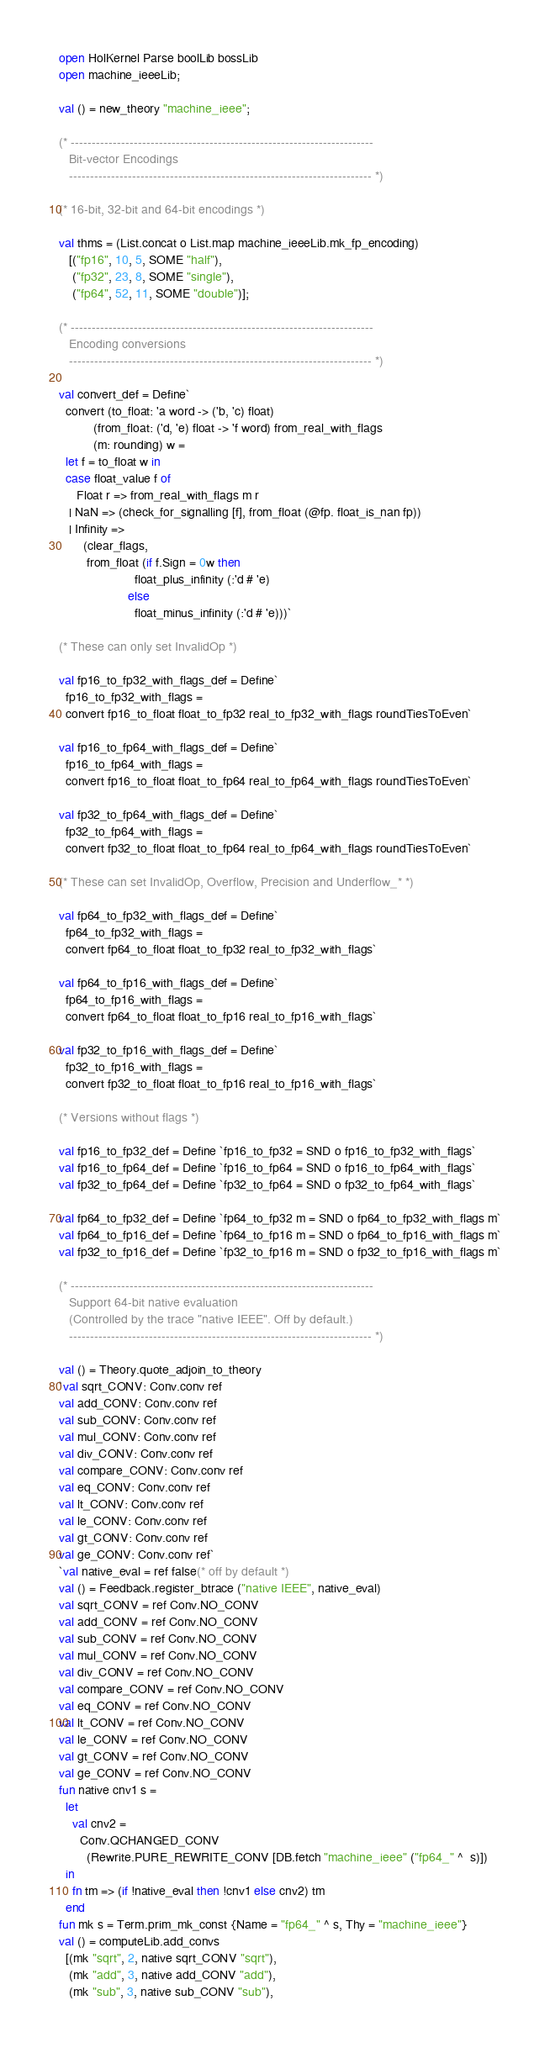<code> <loc_0><loc_0><loc_500><loc_500><_SML_>open HolKernel Parse boolLib bossLib
open machine_ieeeLib;

val () = new_theory "machine_ieee";

(* ------------------------------------------------------------------------
   Bit-vector Encodings
   ------------------------------------------------------------------------ *)

(* 16-bit, 32-bit and 64-bit encodings *)

val thms = (List.concat o List.map machine_ieeeLib.mk_fp_encoding)
   [("fp16", 10, 5, SOME "half"),
    ("fp32", 23, 8, SOME "single"),
    ("fp64", 52, 11, SOME "double")];

(* ------------------------------------------------------------------------
   Encoding conversions
   ------------------------------------------------------------------------ *)

val convert_def = Define`
  convert (to_float: 'a word -> ('b, 'c) float)
          (from_float: ('d, 'e) float -> 'f word) from_real_with_flags
          (m: rounding) w =
  let f = to_float w in
  case float_value f of
     Float r => from_real_with_flags m r
   | NaN => (check_for_signalling [f], from_float (@fp. float_is_nan fp))
   | Infinity =>
       (clear_flags,
        from_float (if f.Sign = 0w then
                      float_plus_infinity (:'d # 'e)
                    else
                      float_minus_infinity (:'d # 'e)))`

(* These can only set InvalidOp *)

val fp16_to_fp32_with_flags_def = Define`
  fp16_to_fp32_with_flags =
  convert fp16_to_float float_to_fp32 real_to_fp32_with_flags roundTiesToEven`

val fp16_to_fp64_with_flags_def = Define`
  fp16_to_fp64_with_flags =
  convert fp16_to_float float_to_fp64 real_to_fp64_with_flags roundTiesToEven`

val fp32_to_fp64_with_flags_def = Define`
  fp32_to_fp64_with_flags =
  convert fp32_to_float float_to_fp64 real_to_fp64_with_flags roundTiesToEven`

(* These can set InvalidOp, Overflow, Precision and Underflow_* *)

val fp64_to_fp32_with_flags_def = Define`
  fp64_to_fp32_with_flags =
  convert fp64_to_float float_to_fp32 real_to_fp32_with_flags`

val fp64_to_fp16_with_flags_def = Define`
  fp64_to_fp16_with_flags =
  convert fp64_to_float float_to_fp16 real_to_fp16_with_flags`

val fp32_to_fp16_with_flags_def = Define`
  fp32_to_fp16_with_flags =
  convert fp32_to_float float_to_fp16 real_to_fp16_with_flags`

(* Versions without flags *)

val fp16_to_fp32_def = Define `fp16_to_fp32 = SND o fp16_to_fp32_with_flags`
val fp16_to_fp64_def = Define `fp16_to_fp64 = SND o fp16_to_fp64_with_flags`
val fp32_to_fp64_def = Define `fp32_to_fp64 = SND o fp32_to_fp64_with_flags`

val fp64_to_fp32_def = Define `fp64_to_fp32 m = SND o fp64_to_fp32_with_flags m`
val fp64_to_fp16_def = Define `fp64_to_fp16 m = SND o fp64_to_fp16_with_flags m`
val fp32_to_fp16_def = Define `fp32_to_fp16 m = SND o fp32_to_fp16_with_flags m`

(* ------------------------------------------------------------------------
   Support 64-bit native evaluation
   (Controlled by the trace "native IEEE". Off by default.)
   ------------------------------------------------------------------------ *)

val () = Theory.quote_adjoin_to_theory
`val sqrt_CONV: Conv.conv ref
val add_CONV: Conv.conv ref
val sub_CONV: Conv.conv ref
val mul_CONV: Conv.conv ref
val div_CONV: Conv.conv ref
val compare_CONV: Conv.conv ref
val eq_CONV: Conv.conv ref
val lt_CONV: Conv.conv ref
val le_CONV: Conv.conv ref
val gt_CONV: Conv.conv ref
val ge_CONV: Conv.conv ref`
`val native_eval = ref false(* off by default *)
val () = Feedback.register_btrace ("native IEEE", native_eval)
val sqrt_CONV = ref Conv.NO_CONV
val add_CONV = ref Conv.NO_CONV
val sub_CONV = ref Conv.NO_CONV
val mul_CONV = ref Conv.NO_CONV
val div_CONV = ref Conv.NO_CONV
val compare_CONV = ref Conv.NO_CONV
val eq_CONV = ref Conv.NO_CONV
val lt_CONV = ref Conv.NO_CONV
val le_CONV = ref Conv.NO_CONV
val gt_CONV = ref Conv.NO_CONV
val ge_CONV = ref Conv.NO_CONV
fun native cnv1 s =
  let
    val cnv2 =
      Conv.QCHANGED_CONV
        (Rewrite.PURE_REWRITE_CONV [DB.fetch "machine_ieee" ("fp64_" ^  s)])
  in
    fn tm => (if !native_eval then !cnv1 else cnv2) tm
  end
fun mk s = Term.prim_mk_const {Name = "fp64_" ^ s, Thy = "machine_ieee"}
val () = computeLib.add_convs
  [(mk "sqrt", 2, native sqrt_CONV "sqrt"),
   (mk "add", 3, native add_CONV "add"),
   (mk "sub", 3, native sub_CONV "sub"),</code> 